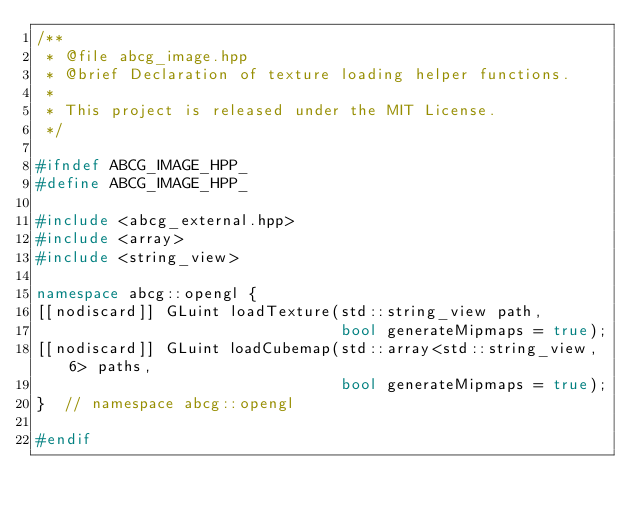Convert code to text. <code><loc_0><loc_0><loc_500><loc_500><_C++_>/**
 * @file abcg_image.hpp
 * @brief Declaration of texture loading helper functions.
 *
 * This project is released under the MIT License.
 */

#ifndef ABCG_IMAGE_HPP_
#define ABCG_IMAGE_HPP_

#include <abcg_external.hpp>
#include <array>
#include <string_view>

namespace abcg::opengl {
[[nodiscard]] GLuint loadTexture(std::string_view path,
                                 bool generateMipmaps = true);
[[nodiscard]] GLuint loadCubemap(std::array<std::string_view, 6> paths,
                                 bool generateMipmaps = true);
}  // namespace abcg::opengl

#endif</code> 